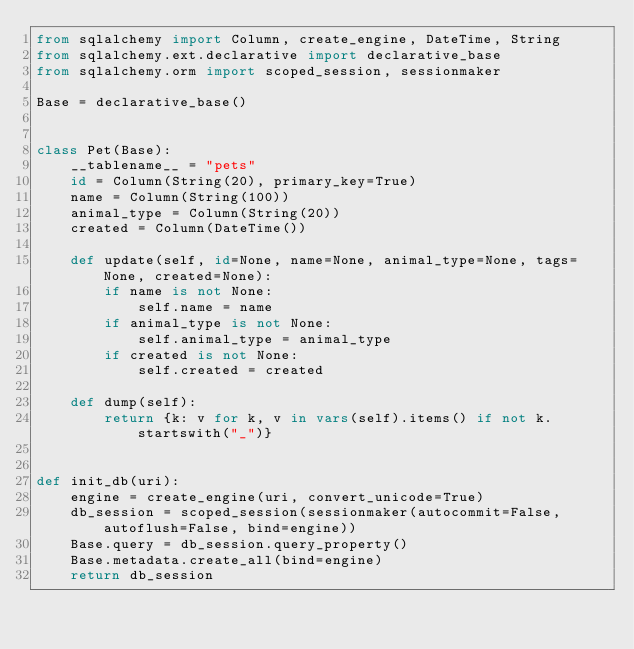<code> <loc_0><loc_0><loc_500><loc_500><_Python_>from sqlalchemy import Column, create_engine, DateTime, String
from sqlalchemy.ext.declarative import declarative_base
from sqlalchemy.orm import scoped_session, sessionmaker

Base = declarative_base()


class Pet(Base):
    __tablename__ = "pets"
    id = Column(String(20), primary_key=True)
    name = Column(String(100))
    animal_type = Column(String(20))
    created = Column(DateTime())

    def update(self, id=None, name=None, animal_type=None, tags=None, created=None):
        if name is not None:
            self.name = name
        if animal_type is not None:
            self.animal_type = animal_type
        if created is not None:
            self.created = created

    def dump(self):
        return {k: v for k, v in vars(self).items() if not k.startswith("_")}


def init_db(uri):
    engine = create_engine(uri, convert_unicode=True)
    db_session = scoped_session(sessionmaker(autocommit=False, autoflush=False, bind=engine))
    Base.query = db_session.query_property()
    Base.metadata.create_all(bind=engine)
    return db_session
</code> 